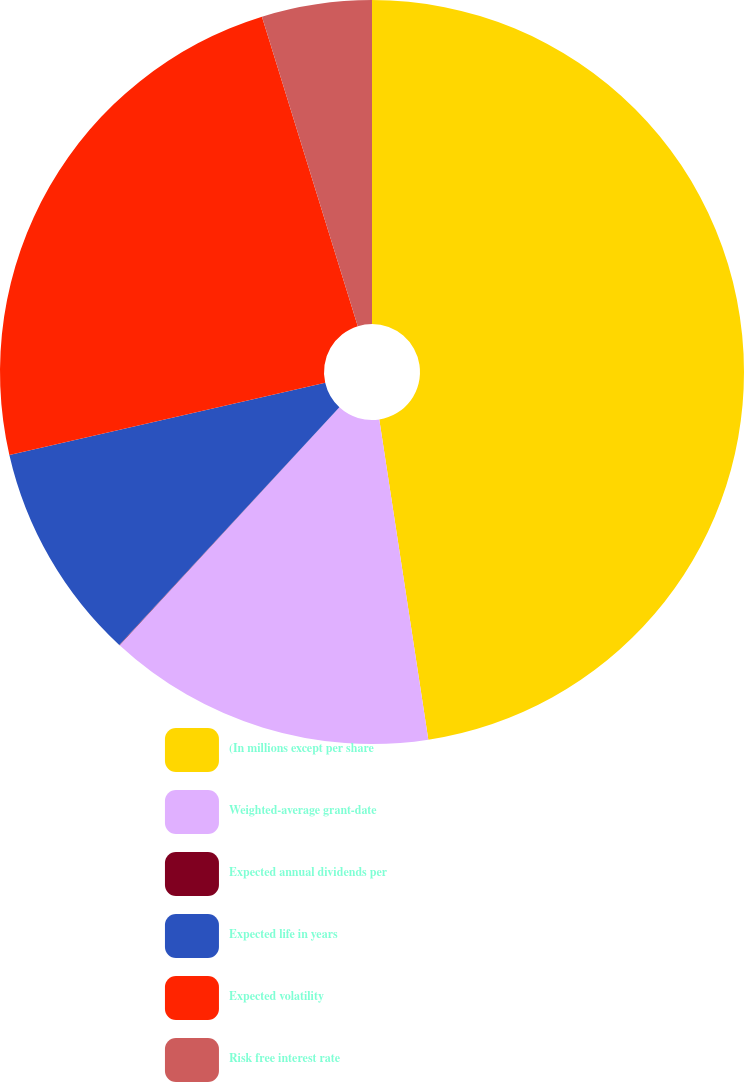Convert chart. <chart><loc_0><loc_0><loc_500><loc_500><pie_chart><fcel>(In millions except per share<fcel>Weighted-average grant-date<fcel>Expected annual dividends per<fcel>Expected life in years<fcel>Expected volatility<fcel>Risk free interest rate<nl><fcel>47.58%<fcel>14.29%<fcel>0.02%<fcel>9.53%<fcel>23.8%<fcel>4.78%<nl></chart> 